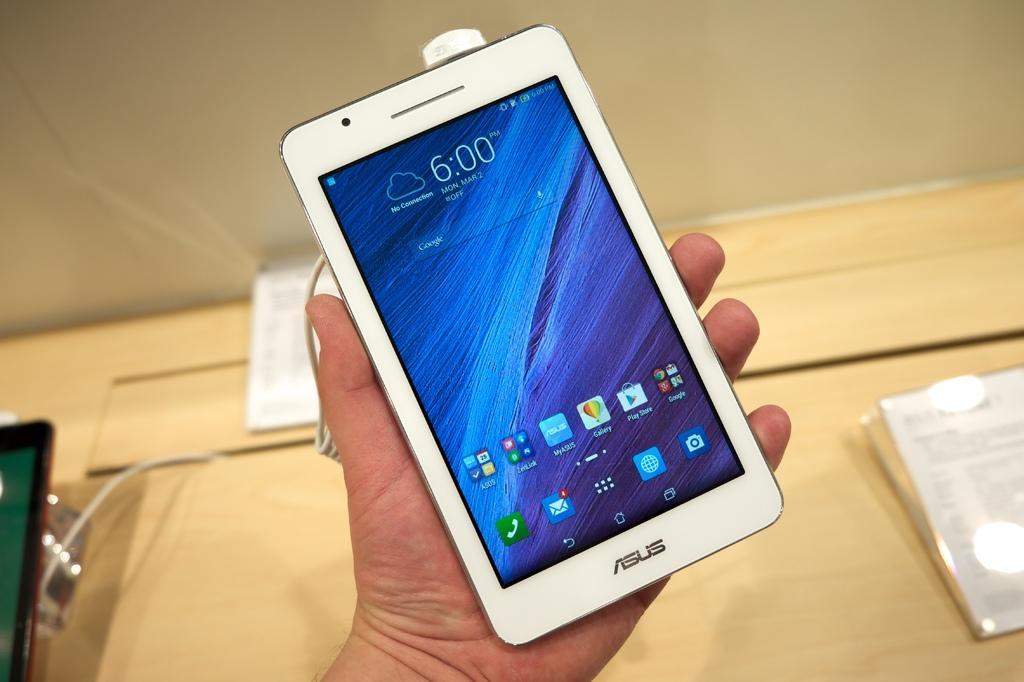Please provide a concise description of this image. In the foreground of this picture we can see the hand of a person holding a white color mobile phone and we can see the numbers, text and the icons on the display of mobile phone. In the background we can see there are some objects placed on the top of the wooden table. 